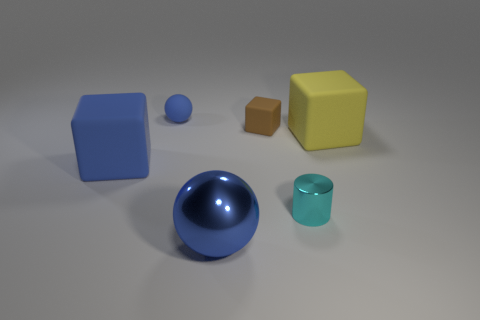There is a matte cube that is left of the shiny sphere; what color is it?
Keep it short and to the point. Blue. Are there any shiny cylinders of the same size as the brown matte block?
Your answer should be very brief. Yes. There is a blue sphere that is the same size as the yellow block; what material is it?
Your answer should be compact. Metal. Do the blue metal object and the blue rubber object to the left of the small ball have the same size?
Provide a succinct answer. Yes. What is the large cube on the right side of the tiny cylinder made of?
Make the answer very short. Rubber. Is the number of brown rubber objects that are right of the brown cube the same as the number of small purple rubber cubes?
Provide a short and direct response. Yes. Does the yellow cube have the same size as the blue matte block?
Provide a short and direct response. Yes. There is a matte cube that is behind the large thing that is on the right side of the cyan metallic cylinder; are there any blocks in front of it?
Your answer should be compact. Yes. There is a big yellow object that is the same shape as the brown thing; what material is it?
Provide a short and direct response. Rubber. There is a big matte block that is to the right of the small cyan object; what number of large matte blocks are in front of it?
Provide a succinct answer. 1. 